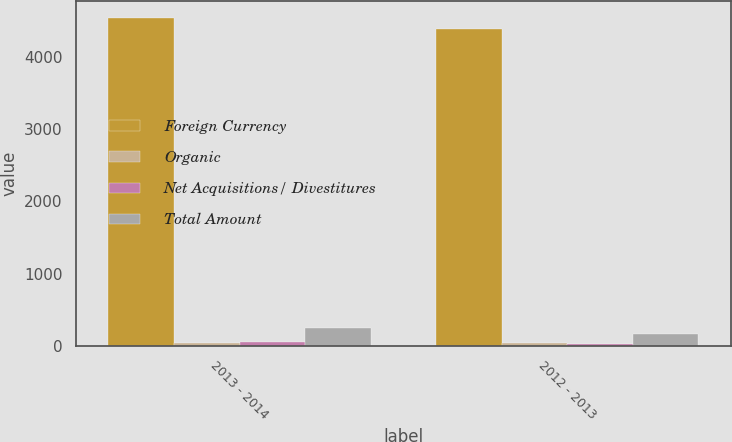<chart> <loc_0><loc_0><loc_500><loc_500><stacked_bar_chart><ecel><fcel>2013 - 2014<fcel>2012 - 2013<nl><fcel>Foreign Currency<fcel>4545.5<fcel>4391.9<nl><fcel>Organic<fcel>38.3<fcel>40.3<nl><fcel>Net Acquisitions/ Divestitures<fcel>59.3<fcel>28.2<nl><fcel>Total Amount<fcel>253.9<fcel>165.7<nl></chart> 